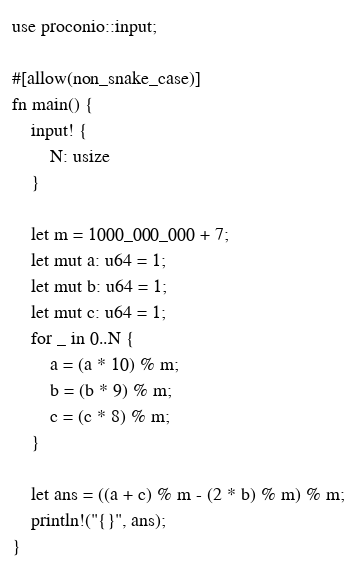Convert code to text. <code><loc_0><loc_0><loc_500><loc_500><_Rust_>use proconio::input;

#[allow(non_snake_case)]
fn main() {
    input! {
        N: usize
    }

    let m = 1000_000_000 + 7;
    let mut a: u64 = 1;
    let mut b: u64 = 1;
    let mut c: u64 = 1;
    for _ in 0..N {
        a = (a * 10) % m;
        b = (b * 9) % m;
        c = (c * 8) % m;
    }

    let ans = ((a + c) % m - (2 * b) % m) % m;
    println!("{}", ans);
}
</code> 